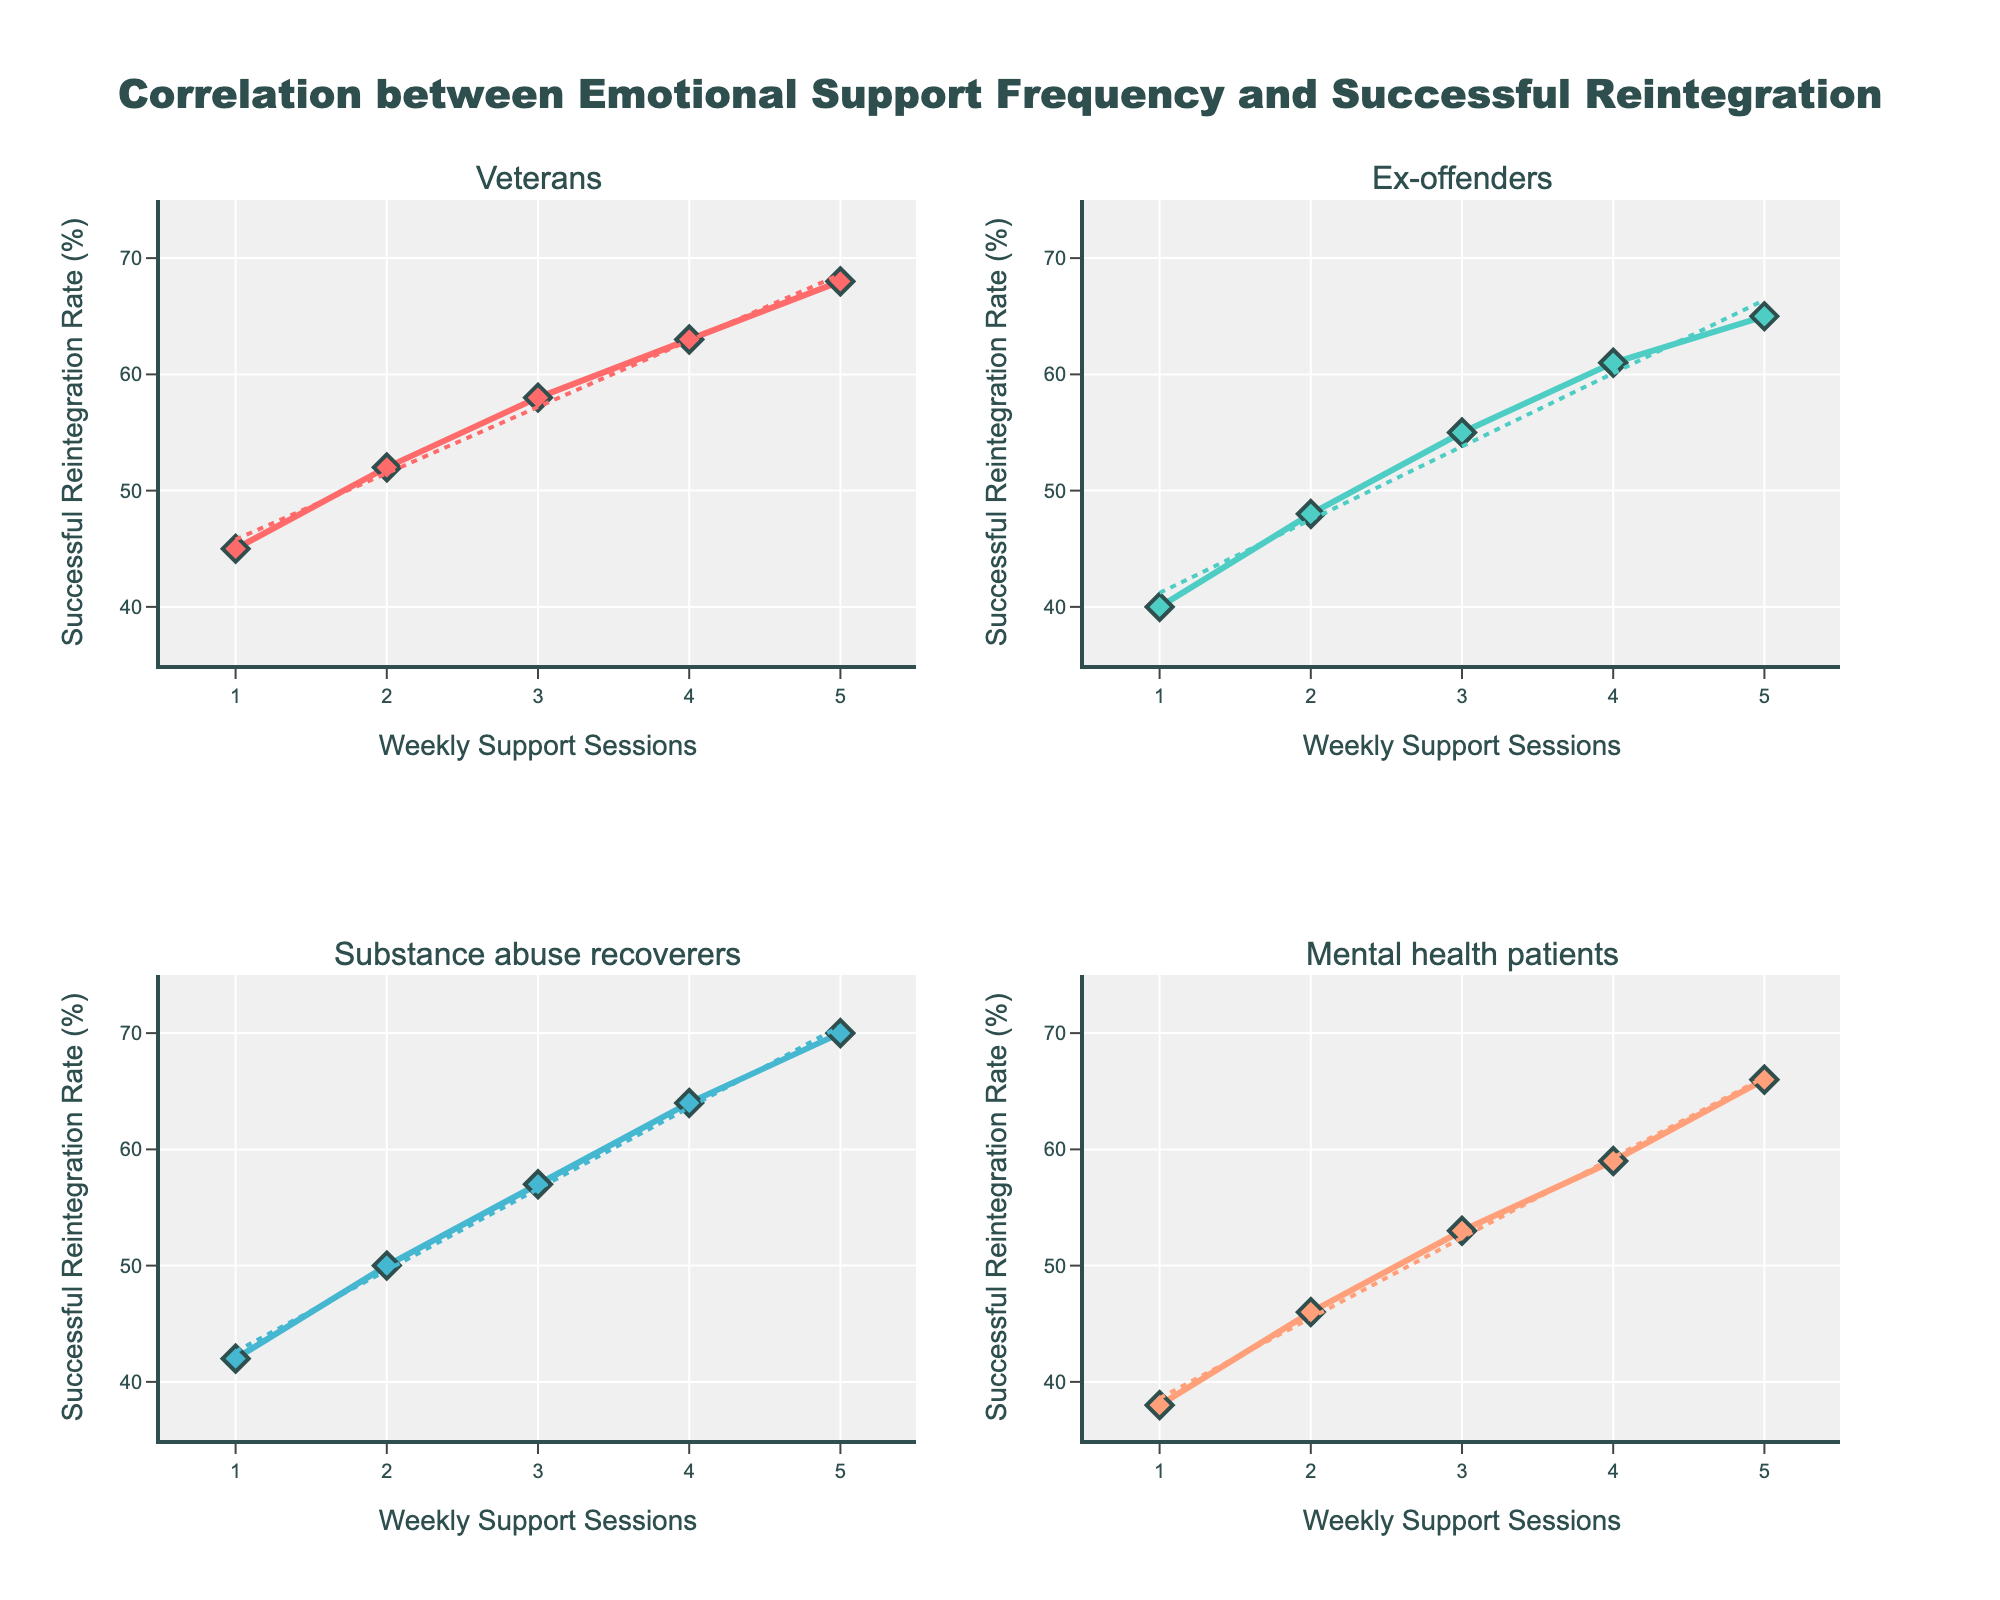What is the title of the figure? The figure's title is usually displayed at the top and summarizes the main idea being visualized. In this case, you can find the title at the top center of the figure.
Answer: Correlation between Emotional Support Frequency and Successful Reintegration Which client group shows the highest successful reintegration rate? To determine the highest successful reintegration rate, identify the group with the data point that has the highest y-axis value (successful reintegration rate).
Answer: Substance abuse recoverers How many weekly support sessions corresponds to a 68% successful reintegration rate for the Veterans group? Look for the data point within the Veterans group where the y-axis value is 68%, and check its corresponding x-axis value (weekly support sessions).
Answer: 5 Which client group has the steepest trendline? To identify the steepest trendline, visually compare the angles (slopes) of the trendlines for each client group—whichever is the most vertical represents the steepest trendline.
Answer: Substance abuse recoverers What is the successful reintegration rate for Ex-offenders when they attend 3 weekly support sessions? Locate the data point in the Ex-offenders subplot where the x-axis value is 3, and read off the corresponding y-axis value (successful reintegration rate).
Answer: 55% Compare the successful reintegration rates for Mental health patients and Veterans when they attend 2 weekly support sessions. Which group has a higher rate? Identify the points for both Mental health patients and Veterans where the x-axis value is 2 and compare the corresponding y-axis values.
Answer: Veterans What is the range of successful reintegration rates for the Substance abuse recoverers group? Check the minimum and maximum y-axis values (successful reintegration rates) for the Substance abuse recoverers group by looking at the data points in its subplot.
Answer: 42% - 70% On average, how much does the successful reintegration rate improve per additional weekly support session for the Veterans group? Calculate the difference between the highest and lowest successful reintegration rates for the Veterans group, and divide by the number of weekly support sessions minus one (since the rate improvement per session is linear).
Answer: 5.75% per session Is there a visible positive correlation between weekly support sessions and successful reintegration rates across all groups? Observe the direction of the data points and trendlines—if they generally increase from left to right, a positive correlation exists.
Answer: Yes 